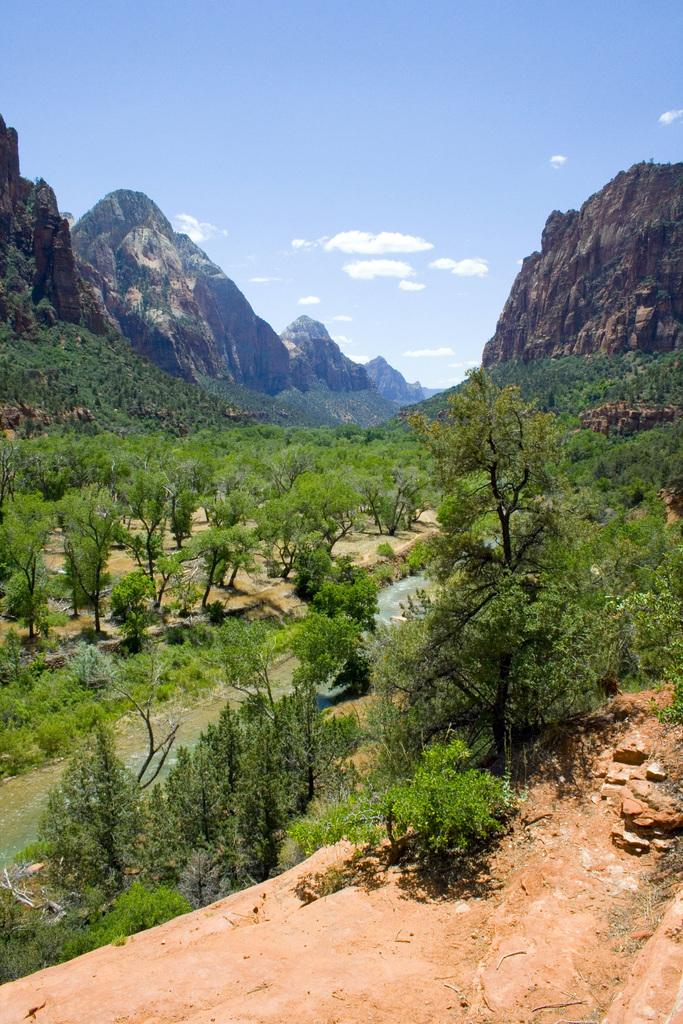What type of vegetation can be seen in the image? There are trees in the image. What natural element is visible in the image besides the trees? There is water visible in the image. What type of landscape feature is present in the background of the image? There are mountains in the background of the image. What is the condition of the sky in the background of the image? The sky is clear in the background of the image. What book is the water reading in the image? There is no book or reading activity present in the image; it features trees, water, mountains, and a clear sky. What decision is being made by the water in the image? There is no decision-making process involving water in the image; it is simply a natural element visible in the scene. 